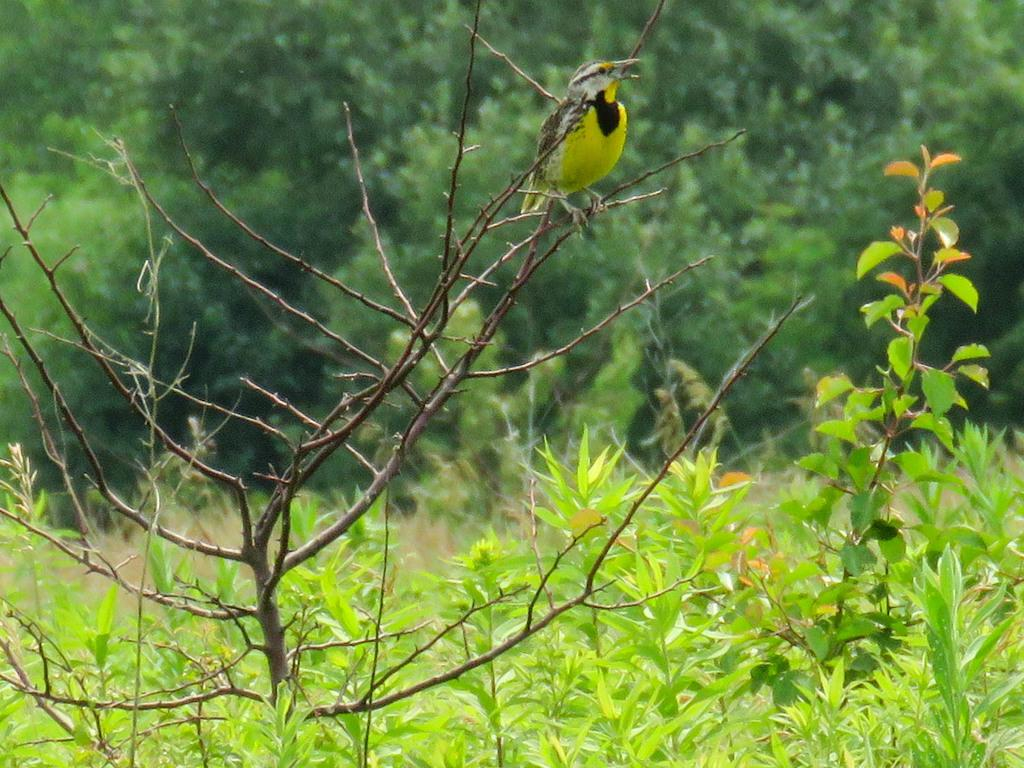What type of animal can be seen in the image? There is a bird in the image. Where is the bird located in the image? The bird is standing on a branch of a plant. What else can be seen in the image besides the bird? There are other plants visible in the image. What can be seen in the background of the image? There are plants, trees, and the ground visible in the background of the image. What type of coach is the bird using to travel in the image? There is no coach present in the image; it features a bird standing on a branch of a plant. What is the bird's belief about the airplane in the image? There is no airplane present in the image, so the bird's belief about it cannot be determined. 